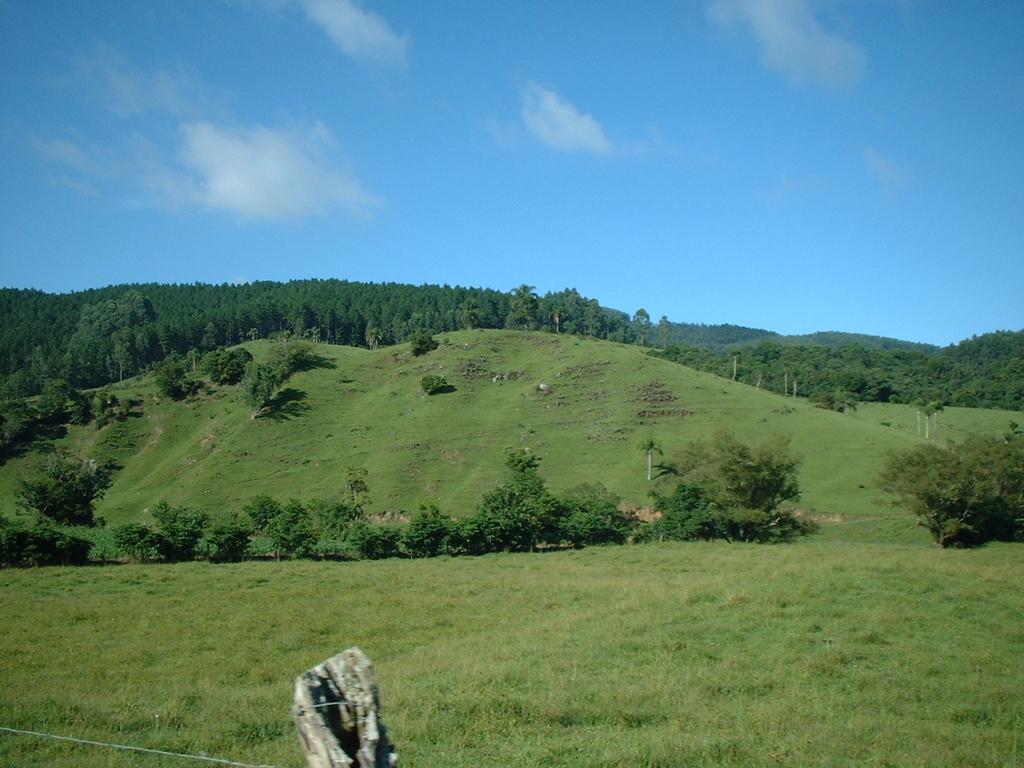Could you give a brief overview of what you see in this image? In the picture I can see the natural scenery of green grass and trees. I can see the metal wire fence on the bottom left side of the picture. There are clouds in the sky. 